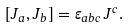Convert formula to latex. <formula><loc_0><loc_0><loc_500><loc_500>\left [ J _ { a } , J _ { b } \right ] = \varepsilon _ { a b c } \, J ^ { c } .</formula> 